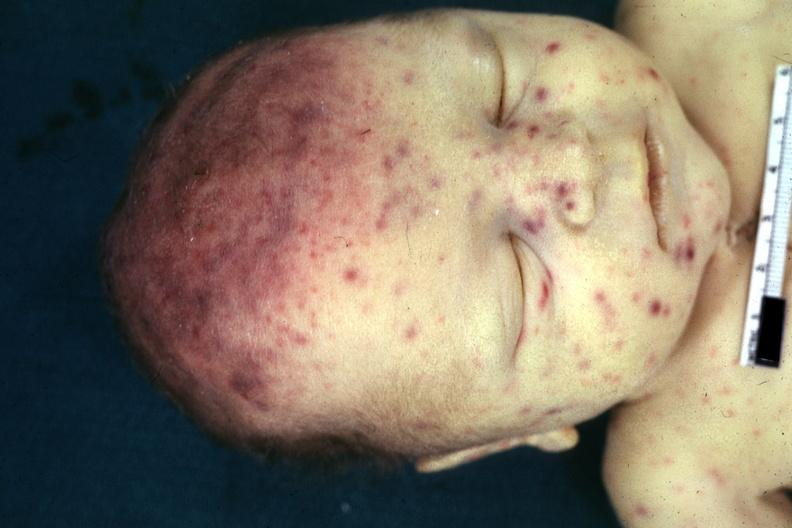does this image show face jaundice and multiple petechial and purpuric hemorrhages?
Answer the question using a single word or phrase. Yes 